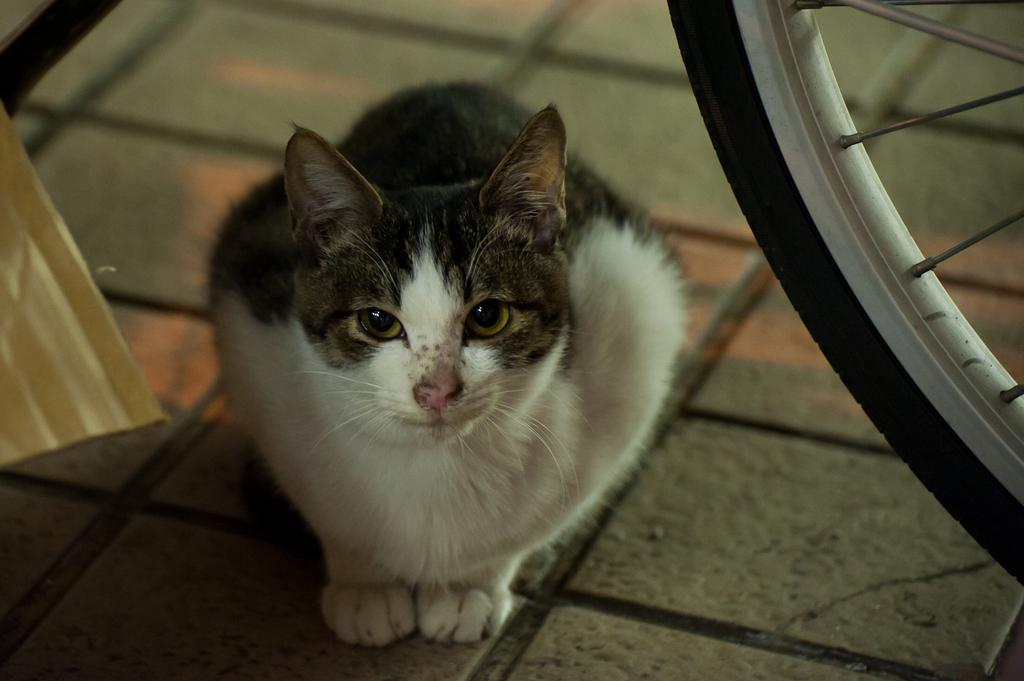What type of animal is on the floor in the image? There is a cat on the floor in the image. What else can be seen on the right side of the image? There is a wheel of a bicycle on the right side of the image. What type of dinosaurs can be seen in the market in the image? There are no dinosaurs or market present in the image; it features a cat on the floor and a wheel of a bicycle on the right side. 